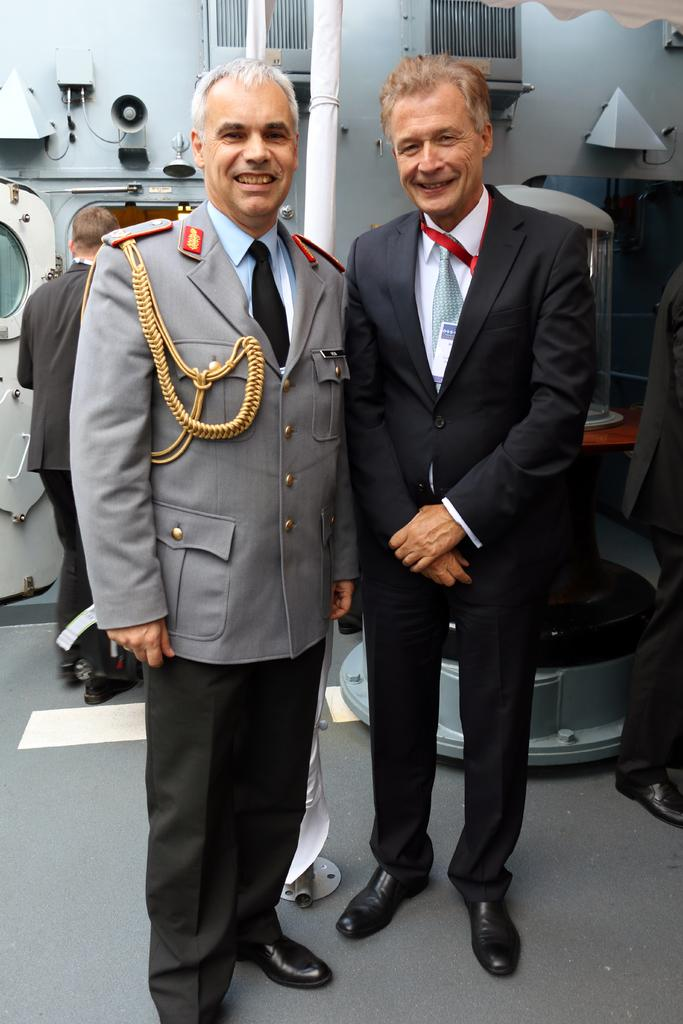How many persons are visible in the image? There are persons standing in the image. What are the persons in the center of the image doing? In the center, there are persons standing and smiling. What can be seen in the background of the image? There is a speaker and a door in the background of the image. What type of picture is hanging on the wall in the image? There is no picture hanging on the wall in the image. Is there a spy present in the image? There is no indication of a spy in the image. What can be used to cut materials in the image? There are no scissors present in the image. 